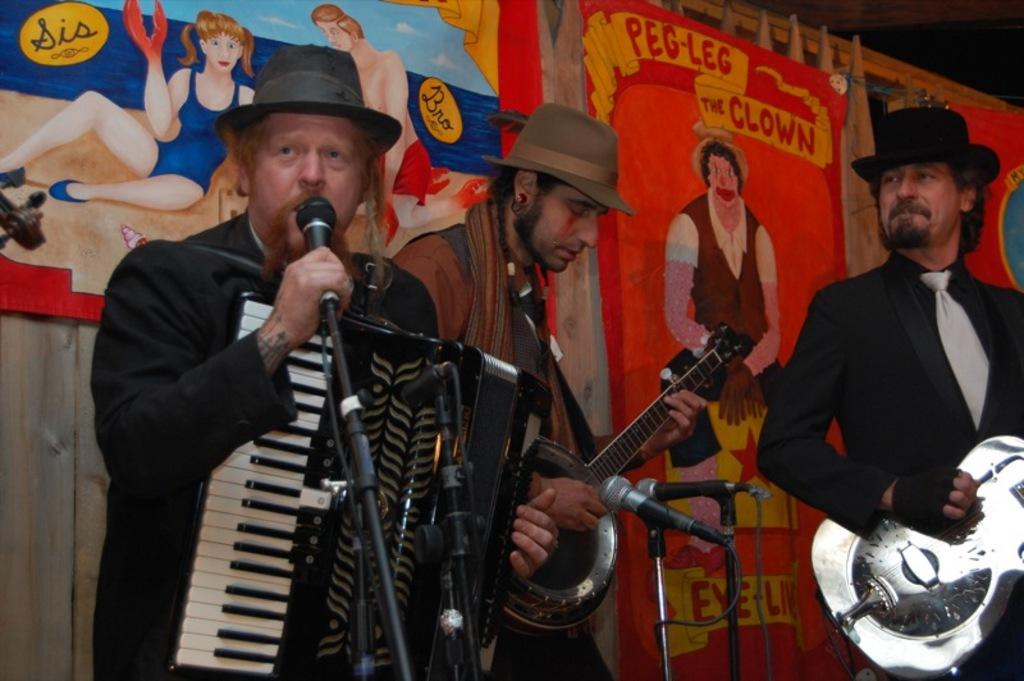How many people are playing musical instruments in the image? There are three people playing musical instruments in the image. What is happening in front of the people? There are mice in front of the people. What can be seen hanging on the wooden wall behind the people? There is a banner with images hanging on a wooden wall behind the people. Can you tell me how many times the mice have bitten the people in the image? There is no indication in the image that the mice have bitten the people, so it cannot be determined from the picture. 